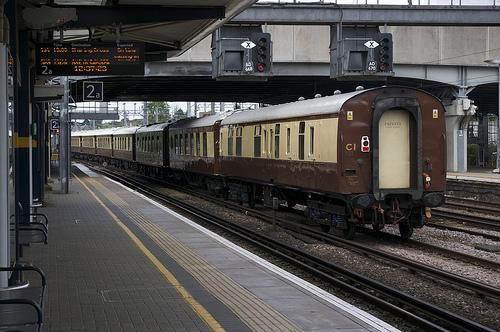Question: why is no one outside of the terminal?
Choices:
A. The bus station is closed.
B. No planes are scheduled to board anytime soon.
C. It doesn't open for a few more hours.
D. They departed.
Answer with the letter. Answer: D Question: how many boxcars are contained fully in the photo?
Choices:
A. Four.
B. Three.
C. Seven.
D. Two.
Answer with the letter. Answer: C Question: where can people waiting relax?
Choices:
A. On benches.
B. In the building.
C. Under the umbrellas.
D. In the park.
Answer with the letter. Answer: A Question: what time of day does it appear to be?
Choices:
A. Nighttime.
B. Midday.
C. Evening.
D. Morning.
Answer with the letter. Answer: B Question: what specific terminal is photographed?
Choices:
A. 3b.
B. 4a.
C. 2a.
D. 5b.
Answer with the letter. Answer: C 